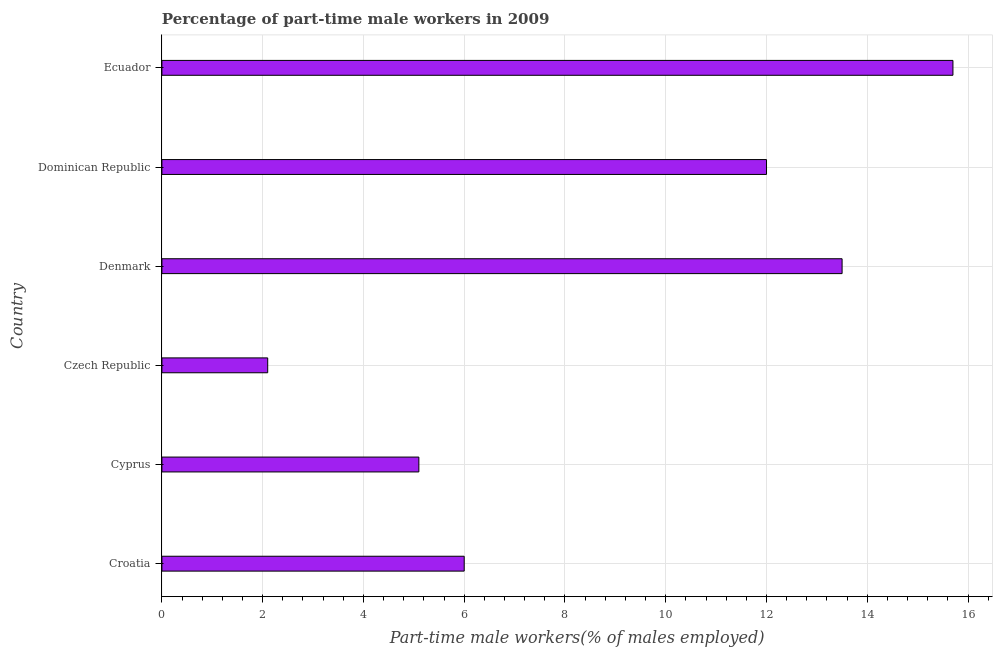Does the graph contain grids?
Your answer should be compact. Yes. What is the title of the graph?
Offer a very short reply. Percentage of part-time male workers in 2009. What is the label or title of the X-axis?
Your answer should be very brief. Part-time male workers(% of males employed). What is the label or title of the Y-axis?
Provide a succinct answer. Country. What is the percentage of part-time male workers in Czech Republic?
Keep it short and to the point. 2.1. Across all countries, what is the maximum percentage of part-time male workers?
Keep it short and to the point. 15.7. Across all countries, what is the minimum percentage of part-time male workers?
Ensure brevity in your answer.  2.1. In which country was the percentage of part-time male workers maximum?
Provide a short and direct response. Ecuador. In which country was the percentage of part-time male workers minimum?
Offer a very short reply. Czech Republic. What is the sum of the percentage of part-time male workers?
Provide a succinct answer. 54.4. What is the average percentage of part-time male workers per country?
Keep it short and to the point. 9.07. In how many countries, is the percentage of part-time male workers greater than 5.2 %?
Give a very brief answer. 4. What is the ratio of the percentage of part-time male workers in Croatia to that in Denmark?
Offer a very short reply. 0.44. Is the percentage of part-time male workers in Denmark less than that in Dominican Republic?
Keep it short and to the point. No. Is the sum of the percentage of part-time male workers in Croatia and Cyprus greater than the maximum percentage of part-time male workers across all countries?
Give a very brief answer. No. In how many countries, is the percentage of part-time male workers greater than the average percentage of part-time male workers taken over all countries?
Keep it short and to the point. 3. What is the difference between two consecutive major ticks on the X-axis?
Ensure brevity in your answer.  2. What is the Part-time male workers(% of males employed) in Croatia?
Your response must be concise. 6. What is the Part-time male workers(% of males employed) in Cyprus?
Provide a short and direct response. 5.1. What is the Part-time male workers(% of males employed) of Czech Republic?
Your answer should be very brief. 2.1. What is the Part-time male workers(% of males employed) in Denmark?
Your answer should be compact. 13.5. What is the Part-time male workers(% of males employed) of Ecuador?
Your response must be concise. 15.7. What is the difference between the Part-time male workers(% of males employed) in Croatia and Cyprus?
Ensure brevity in your answer.  0.9. What is the difference between the Part-time male workers(% of males employed) in Croatia and Czech Republic?
Give a very brief answer. 3.9. What is the difference between the Part-time male workers(% of males employed) in Croatia and Dominican Republic?
Keep it short and to the point. -6. What is the difference between the Part-time male workers(% of males employed) in Cyprus and Czech Republic?
Provide a succinct answer. 3. What is the difference between the Part-time male workers(% of males employed) in Cyprus and Denmark?
Your answer should be very brief. -8.4. What is the difference between the Part-time male workers(% of males employed) in Cyprus and Dominican Republic?
Give a very brief answer. -6.9. What is the difference between the Part-time male workers(% of males employed) in Cyprus and Ecuador?
Make the answer very short. -10.6. What is the difference between the Part-time male workers(% of males employed) in Czech Republic and Dominican Republic?
Make the answer very short. -9.9. What is the difference between the Part-time male workers(% of males employed) in Czech Republic and Ecuador?
Your answer should be very brief. -13.6. What is the difference between the Part-time male workers(% of males employed) in Denmark and Dominican Republic?
Provide a short and direct response. 1.5. What is the difference between the Part-time male workers(% of males employed) in Dominican Republic and Ecuador?
Keep it short and to the point. -3.7. What is the ratio of the Part-time male workers(% of males employed) in Croatia to that in Cyprus?
Your response must be concise. 1.18. What is the ratio of the Part-time male workers(% of males employed) in Croatia to that in Czech Republic?
Keep it short and to the point. 2.86. What is the ratio of the Part-time male workers(% of males employed) in Croatia to that in Denmark?
Keep it short and to the point. 0.44. What is the ratio of the Part-time male workers(% of males employed) in Croatia to that in Dominican Republic?
Your answer should be very brief. 0.5. What is the ratio of the Part-time male workers(% of males employed) in Croatia to that in Ecuador?
Offer a terse response. 0.38. What is the ratio of the Part-time male workers(% of males employed) in Cyprus to that in Czech Republic?
Offer a terse response. 2.43. What is the ratio of the Part-time male workers(% of males employed) in Cyprus to that in Denmark?
Ensure brevity in your answer.  0.38. What is the ratio of the Part-time male workers(% of males employed) in Cyprus to that in Dominican Republic?
Give a very brief answer. 0.42. What is the ratio of the Part-time male workers(% of males employed) in Cyprus to that in Ecuador?
Your answer should be very brief. 0.33. What is the ratio of the Part-time male workers(% of males employed) in Czech Republic to that in Denmark?
Provide a short and direct response. 0.16. What is the ratio of the Part-time male workers(% of males employed) in Czech Republic to that in Dominican Republic?
Your answer should be compact. 0.17. What is the ratio of the Part-time male workers(% of males employed) in Czech Republic to that in Ecuador?
Provide a succinct answer. 0.13. What is the ratio of the Part-time male workers(% of males employed) in Denmark to that in Dominican Republic?
Provide a succinct answer. 1.12. What is the ratio of the Part-time male workers(% of males employed) in Denmark to that in Ecuador?
Offer a terse response. 0.86. What is the ratio of the Part-time male workers(% of males employed) in Dominican Republic to that in Ecuador?
Make the answer very short. 0.76. 